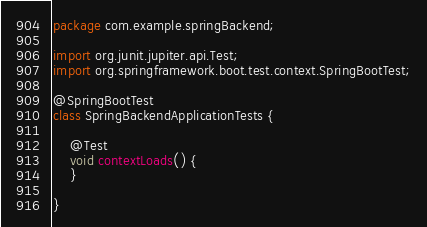Convert code to text. <code><loc_0><loc_0><loc_500><loc_500><_Java_>package com.example.springBackend;

import org.junit.jupiter.api.Test;
import org.springframework.boot.test.context.SpringBootTest;

@SpringBootTest
class SpringBackendApplicationTests {

	@Test
	void contextLoads() {
	}

}
</code> 